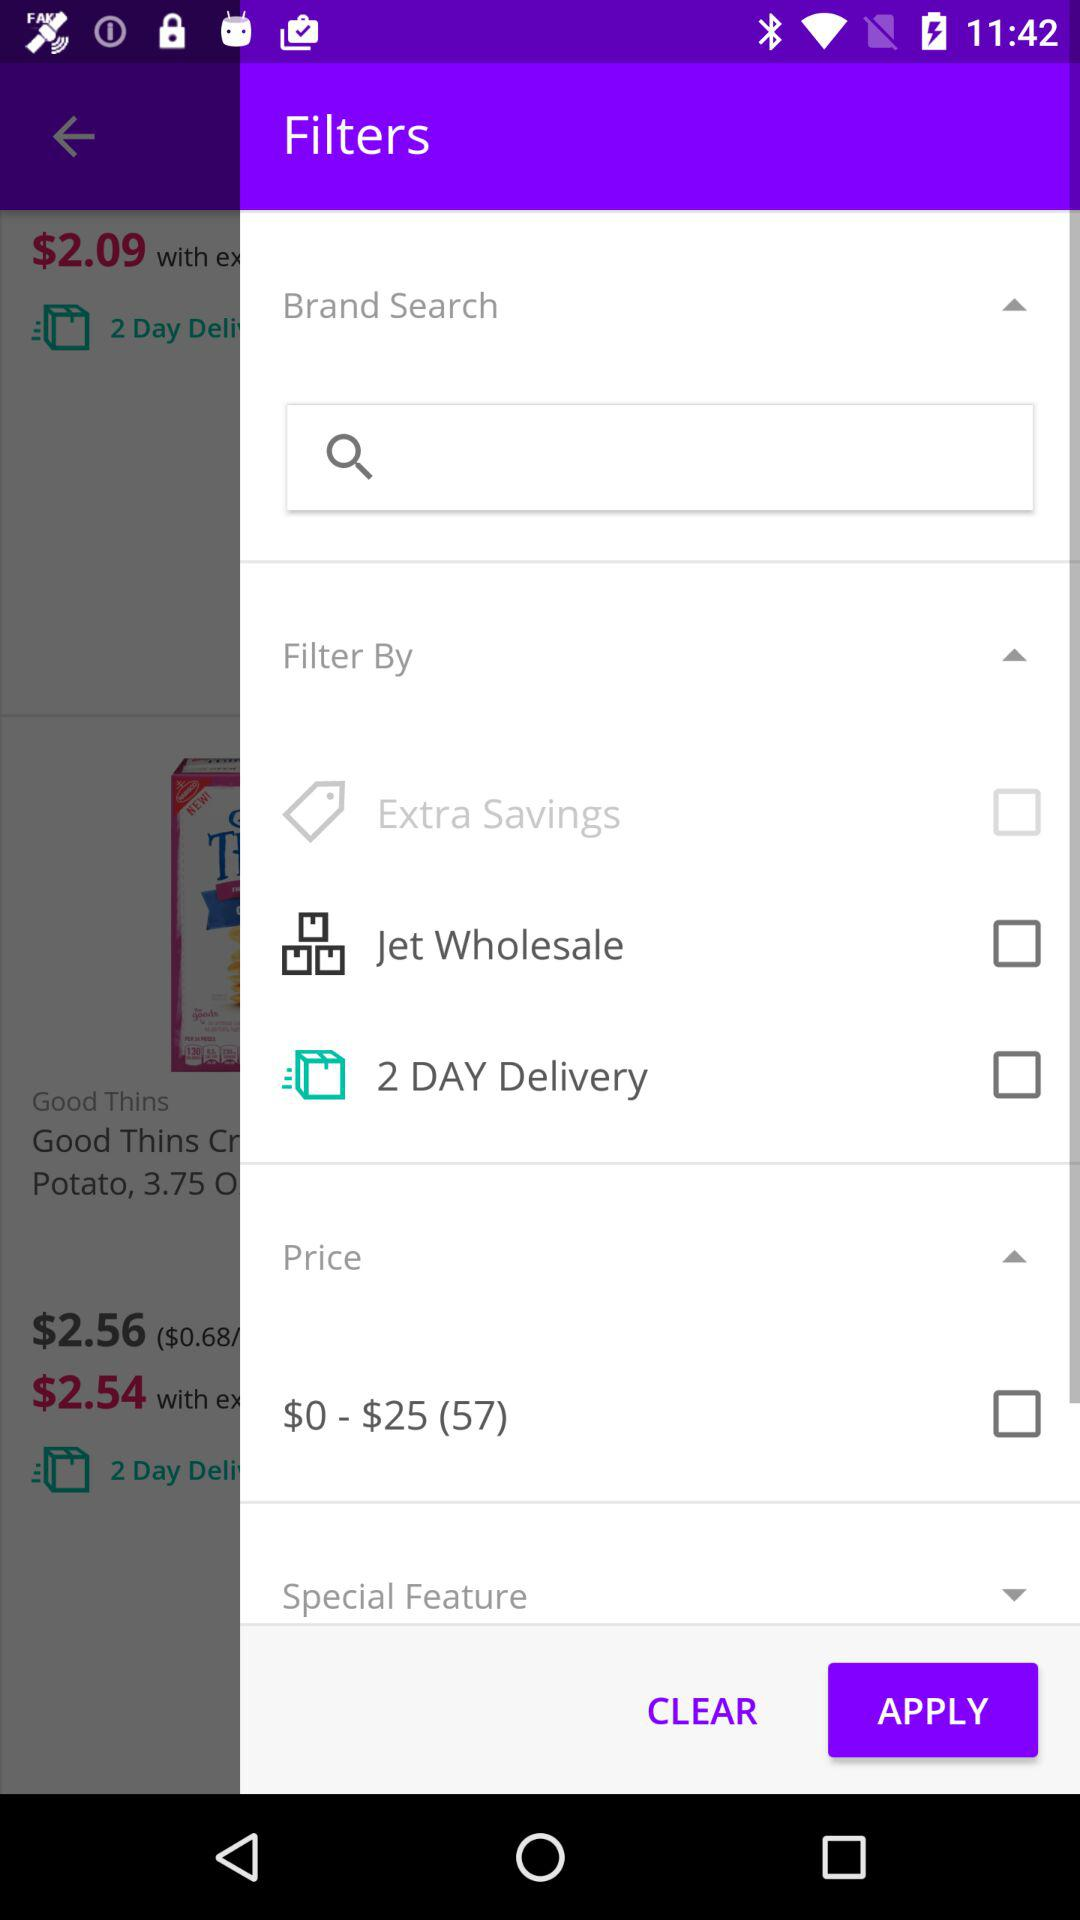How many items are in the price range of $0 - $25?
Answer the question using a single word or phrase. 57 